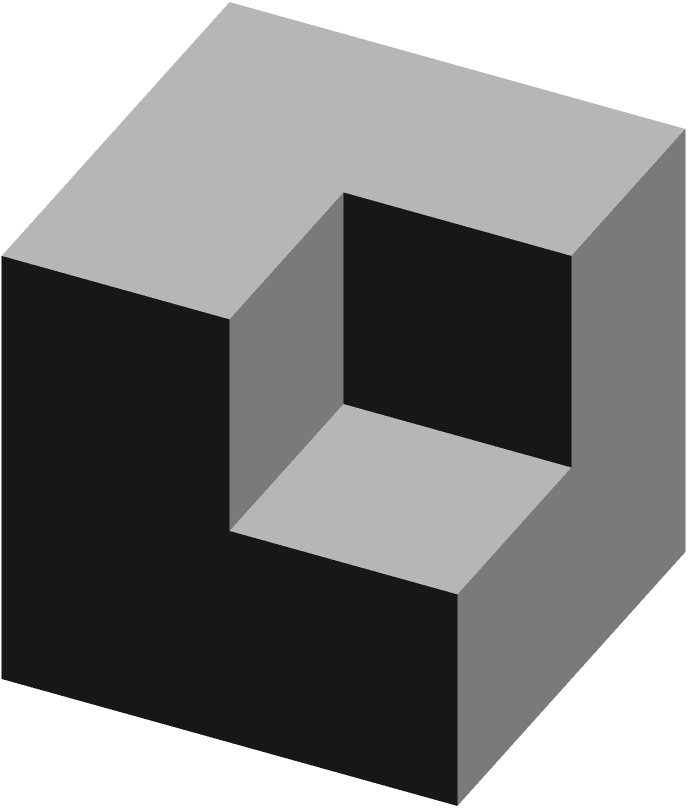Based on the given 3D structure, determine the total number of cubes. The image shows front, top, and side views of the structure. How many cubes are there in total? To determine the total number of cubes, let's analyze the structure step-by-step:

1. Front view:
   - We can see a 2x2 grid of cubes
   - This accounts for 4 cubes

2. Top view:
   - We can see a 2x2 grid of cubes
   - This confirms the 2x2 base we saw in the front view

3. Side view:
   - We can see 2 cubes in the front and 2 cubes in the back
   - This indicates that the structure is 2 cubes deep

4. Combining the information:
   - The base is 2x2 (4 cubes)
   - The structure is 2 cubes high

5. Calculate the total:
   - Bottom layer: 2x2 = 4 cubes
   - Top layer: 2x1 = 2 cubes (note that the top right cube is missing)
   - Total: 4 + 2 = 6 cubes

6. Verify:
   - Count the visible cubes in the 3D representation
   - We can see 6 distinct cubes

Therefore, the total number of cubes in the structure is 6.
Answer: 6 cubes 